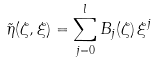<formula> <loc_0><loc_0><loc_500><loc_500>\tilde { \eta } ( \zeta , \xi ) = \sum _ { j = 0 } ^ { l } B _ { j } ( \zeta ) \, \xi ^ { j }</formula> 